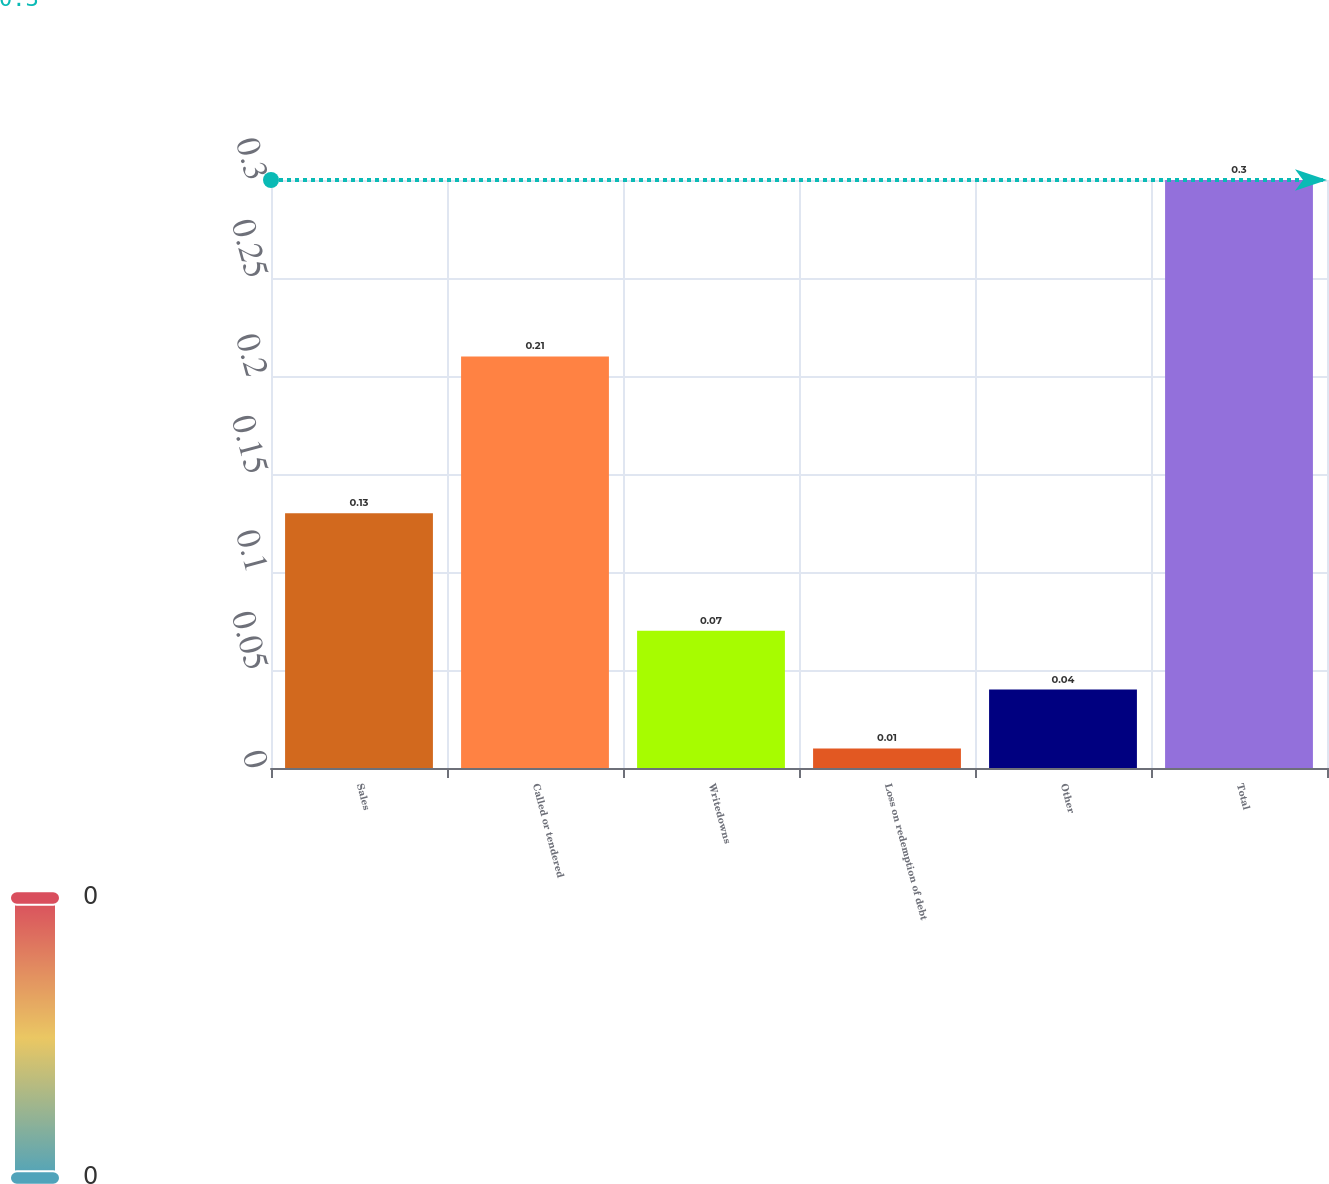<chart> <loc_0><loc_0><loc_500><loc_500><bar_chart><fcel>Sales<fcel>Called or tendered<fcel>Writedowns<fcel>Loss on redemption of debt<fcel>Other<fcel>Total<nl><fcel>0.13<fcel>0.21<fcel>0.07<fcel>0.01<fcel>0.04<fcel>0.3<nl></chart> 